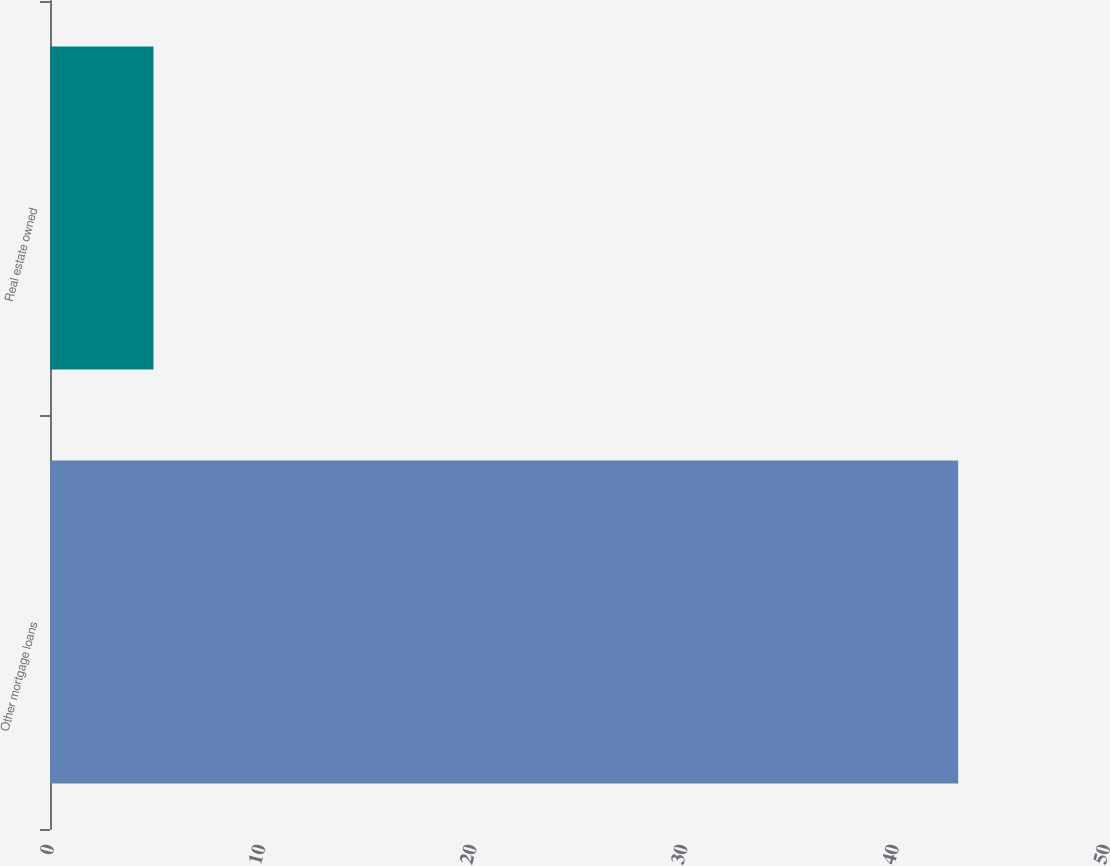Convert chart to OTSL. <chart><loc_0><loc_0><loc_500><loc_500><bar_chart><fcel>Other mortgage loans<fcel>Real estate owned<nl><fcel>43<fcel>4.9<nl></chart> 